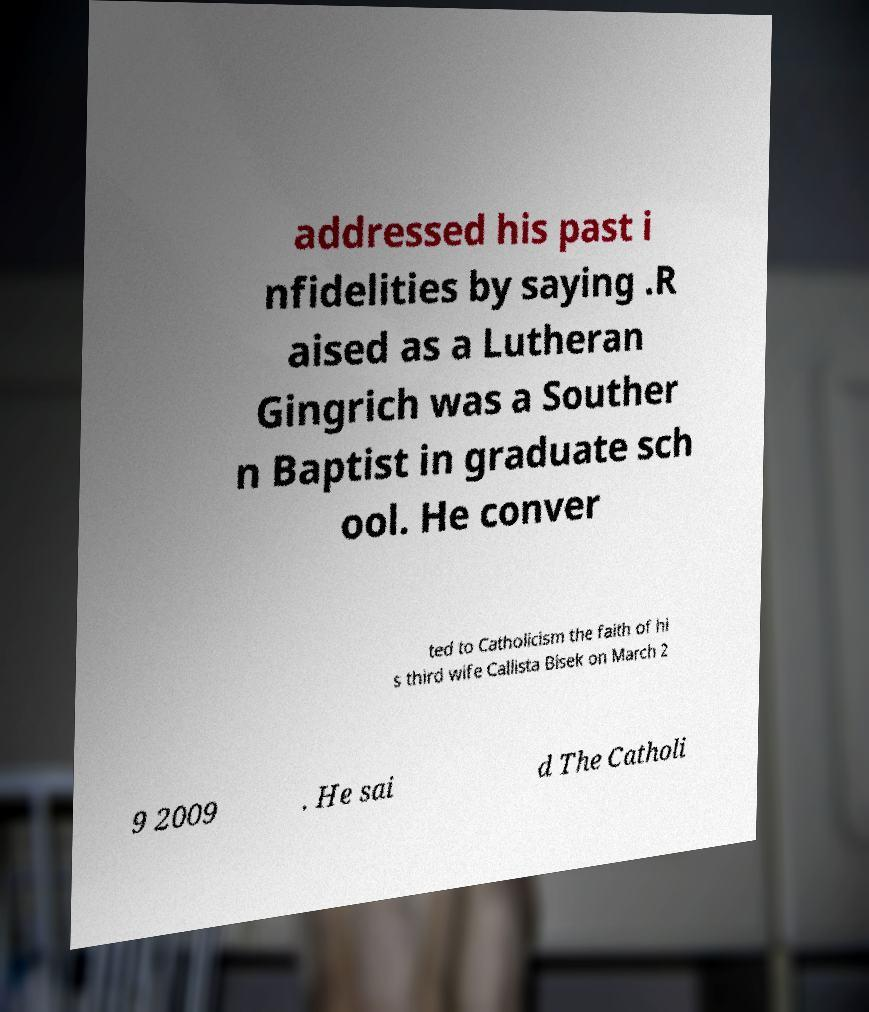Please identify and transcribe the text found in this image. addressed his past i nfidelities by saying .R aised as a Lutheran Gingrich was a Souther n Baptist in graduate sch ool. He conver ted to Catholicism the faith of hi s third wife Callista Bisek on March 2 9 2009 . He sai d The Catholi 